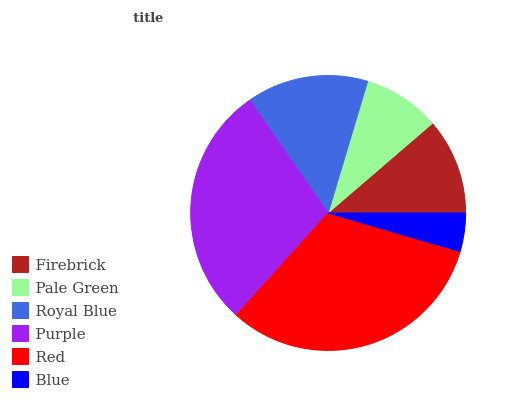Is Blue the minimum?
Answer yes or no. Yes. Is Red the maximum?
Answer yes or no. Yes. Is Pale Green the minimum?
Answer yes or no. No. Is Pale Green the maximum?
Answer yes or no. No. Is Firebrick greater than Pale Green?
Answer yes or no. Yes. Is Pale Green less than Firebrick?
Answer yes or no. Yes. Is Pale Green greater than Firebrick?
Answer yes or no. No. Is Firebrick less than Pale Green?
Answer yes or no. No. Is Royal Blue the high median?
Answer yes or no. Yes. Is Firebrick the low median?
Answer yes or no. Yes. Is Purple the high median?
Answer yes or no. No. Is Red the low median?
Answer yes or no. No. 